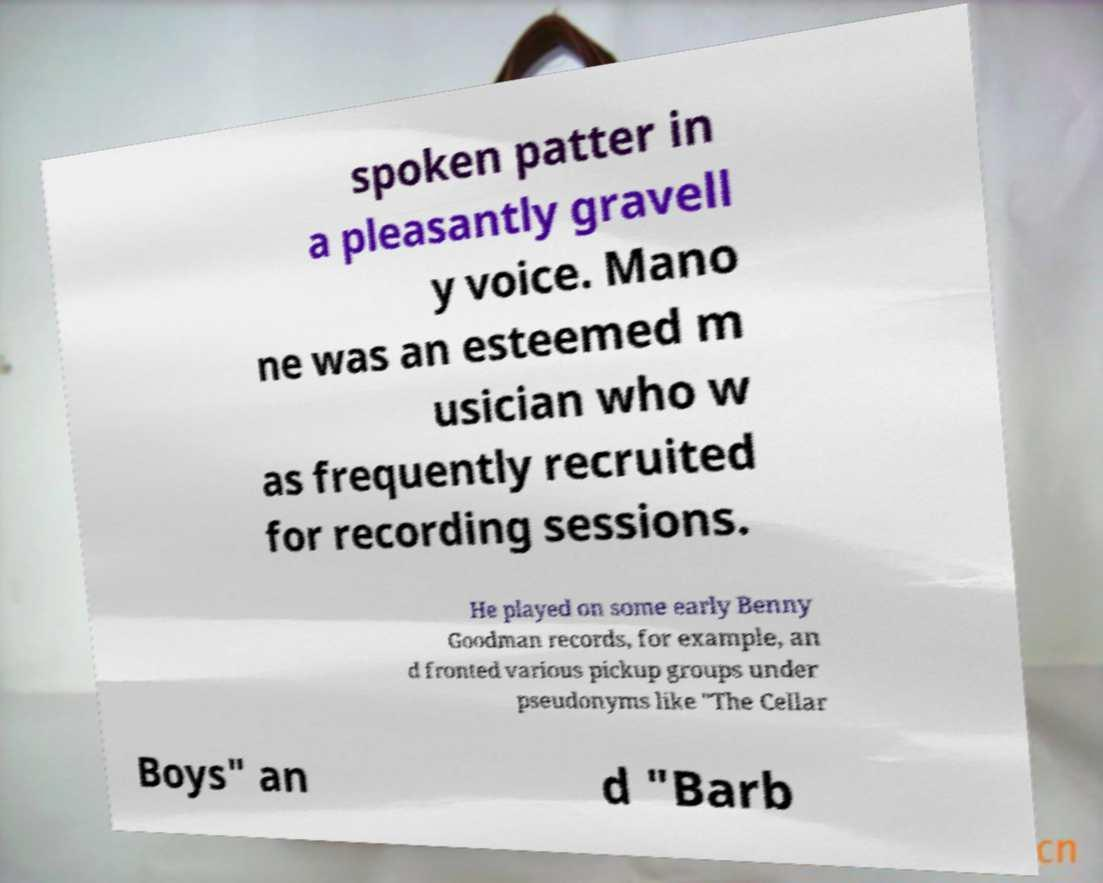Could you assist in decoding the text presented in this image and type it out clearly? spoken patter in a pleasantly gravell y voice. Mano ne was an esteemed m usician who w as frequently recruited for recording sessions. He played on some early Benny Goodman records, for example, an d fronted various pickup groups under pseudonyms like "The Cellar Boys" an d "Barb 